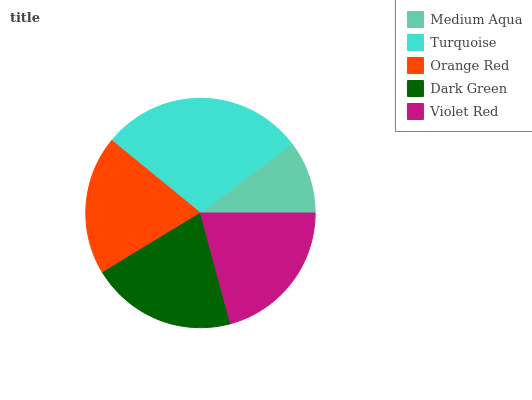Is Medium Aqua the minimum?
Answer yes or no. Yes. Is Turquoise the maximum?
Answer yes or no. Yes. Is Orange Red the minimum?
Answer yes or no. No. Is Orange Red the maximum?
Answer yes or no. No. Is Turquoise greater than Orange Red?
Answer yes or no. Yes. Is Orange Red less than Turquoise?
Answer yes or no. Yes. Is Orange Red greater than Turquoise?
Answer yes or no. No. Is Turquoise less than Orange Red?
Answer yes or no. No. Is Dark Green the high median?
Answer yes or no. Yes. Is Dark Green the low median?
Answer yes or no. Yes. Is Violet Red the high median?
Answer yes or no. No. Is Medium Aqua the low median?
Answer yes or no. No. 